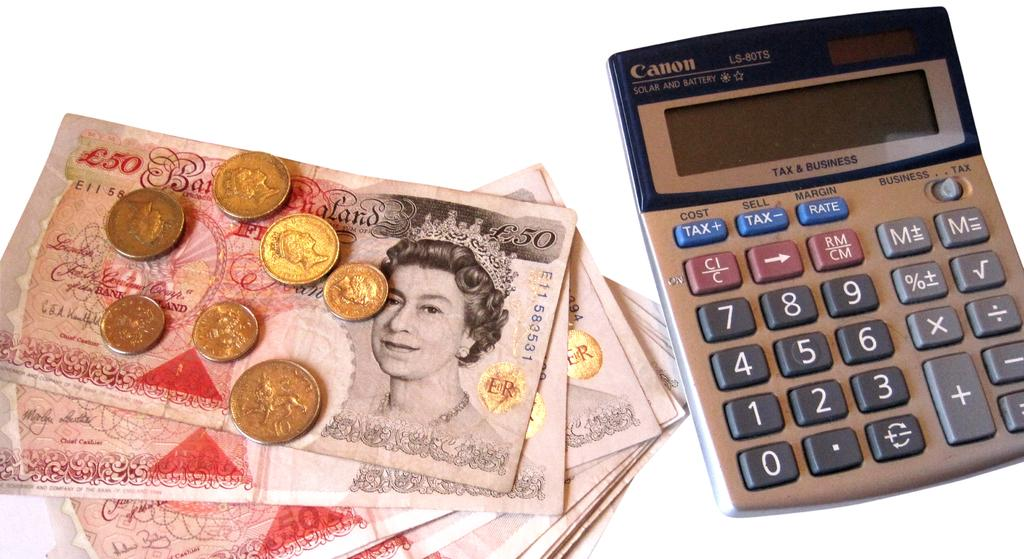Provide a one-sentence caption for the provided image. A canon calculator sits next to paper money and coins. 